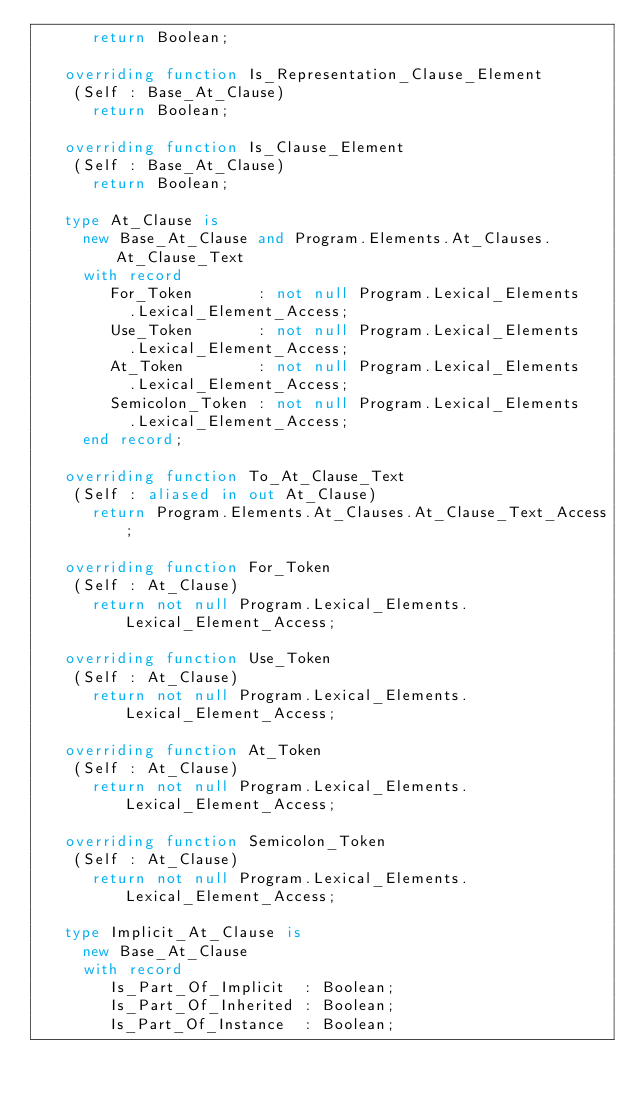<code> <loc_0><loc_0><loc_500><loc_500><_Ada_>      return Boolean;

   overriding function Is_Representation_Clause_Element
    (Self : Base_At_Clause)
      return Boolean;

   overriding function Is_Clause_Element
    (Self : Base_At_Clause)
      return Boolean;

   type At_Clause is
     new Base_At_Clause and Program.Elements.At_Clauses.At_Clause_Text
     with record
        For_Token       : not null Program.Lexical_Elements
          .Lexical_Element_Access;
        Use_Token       : not null Program.Lexical_Elements
          .Lexical_Element_Access;
        At_Token        : not null Program.Lexical_Elements
          .Lexical_Element_Access;
        Semicolon_Token : not null Program.Lexical_Elements
          .Lexical_Element_Access;
     end record;

   overriding function To_At_Clause_Text
    (Self : aliased in out At_Clause)
      return Program.Elements.At_Clauses.At_Clause_Text_Access;

   overriding function For_Token
    (Self : At_Clause)
      return not null Program.Lexical_Elements.Lexical_Element_Access;

   overriding function Use_Token
    (Self : At_Clause)
      return not null Program.Lexical_Elements.Lexical_Element_Access;

   overriding function At_Token
    (Self : At_Clause)
      return not null Program.Lexical_Elements.Lexical_Element_Access;

   overriding function Semicolon_Token
    (Self : At_Clause)
      return not null Program.Lexical_Elements.Lexical_Element_Access;

   type Implicit_At_Clause is
     new Base_At_Clause
     with record
        Is_Part_Of_Implicit  : Boolean;
        Is_Part_Of_Inherited : Boolean;
        Is_Part_Of_Instance  : Boolean;</code> 